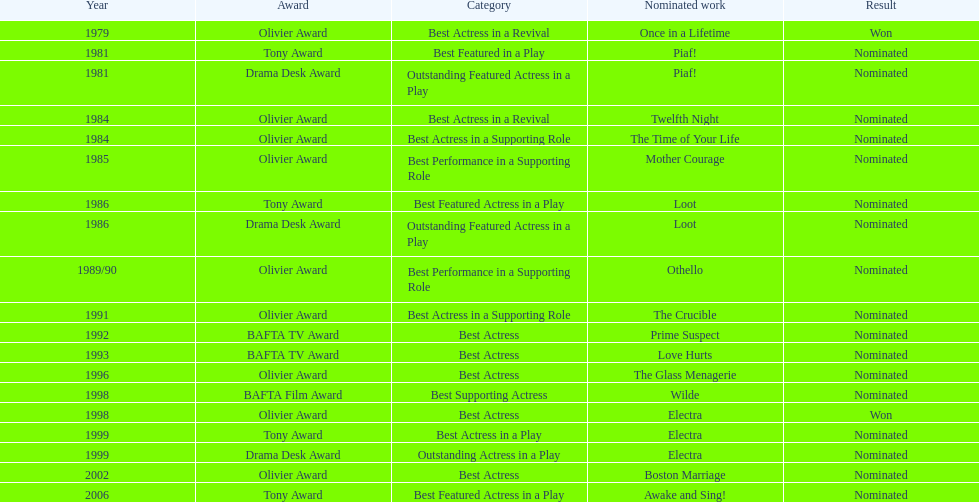What play was wanamaker nominated for best actress in a revival in 1984? Twelfth Night. 